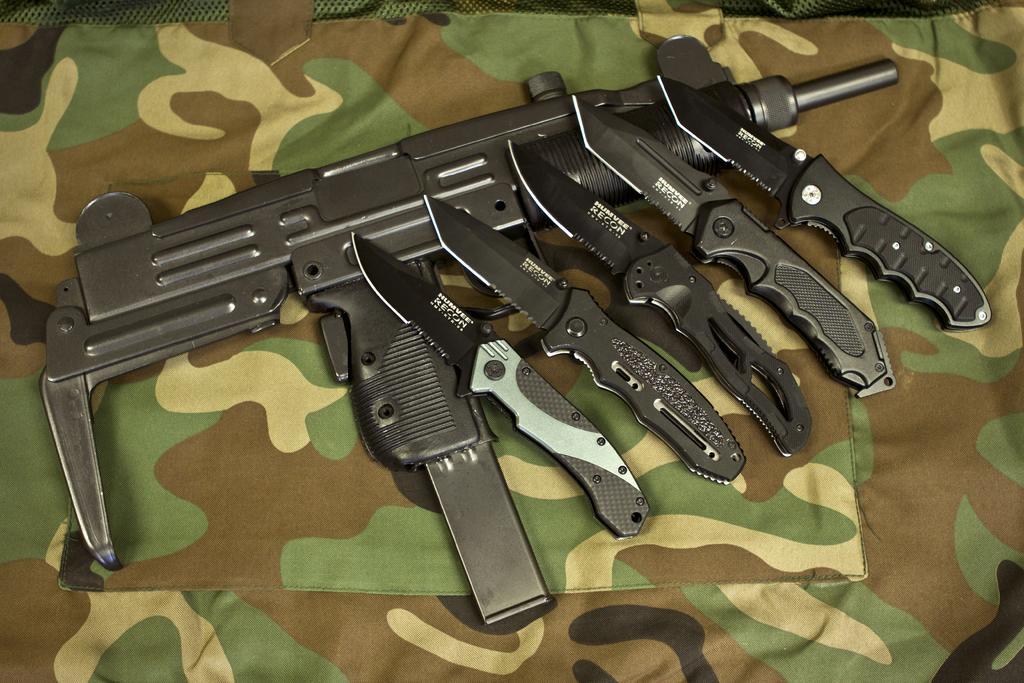How would you summarize this image in a sentence or two? In this image we can see a shooting gun and knives placed on the cloth. 